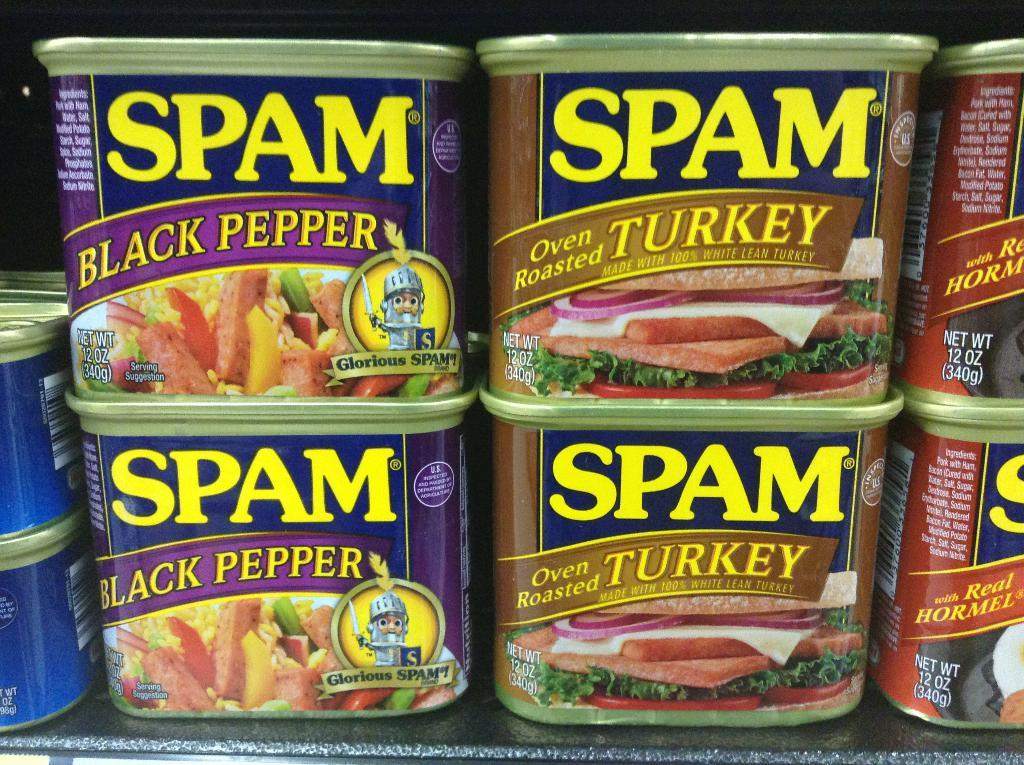What objects are present in the image? There are boxes in the image. What can be seen on the boxes? The boxes have labels on them. Where are the boxes located? The boxes are on a platform. How many fish are swimming in the boxes in the image? There are no fish present in the image; the boxes have labels on them. What type of branch can be seen growing from the boxes in the image? There are no branches present in the image; the boxes have labels on them and are on a platform. 